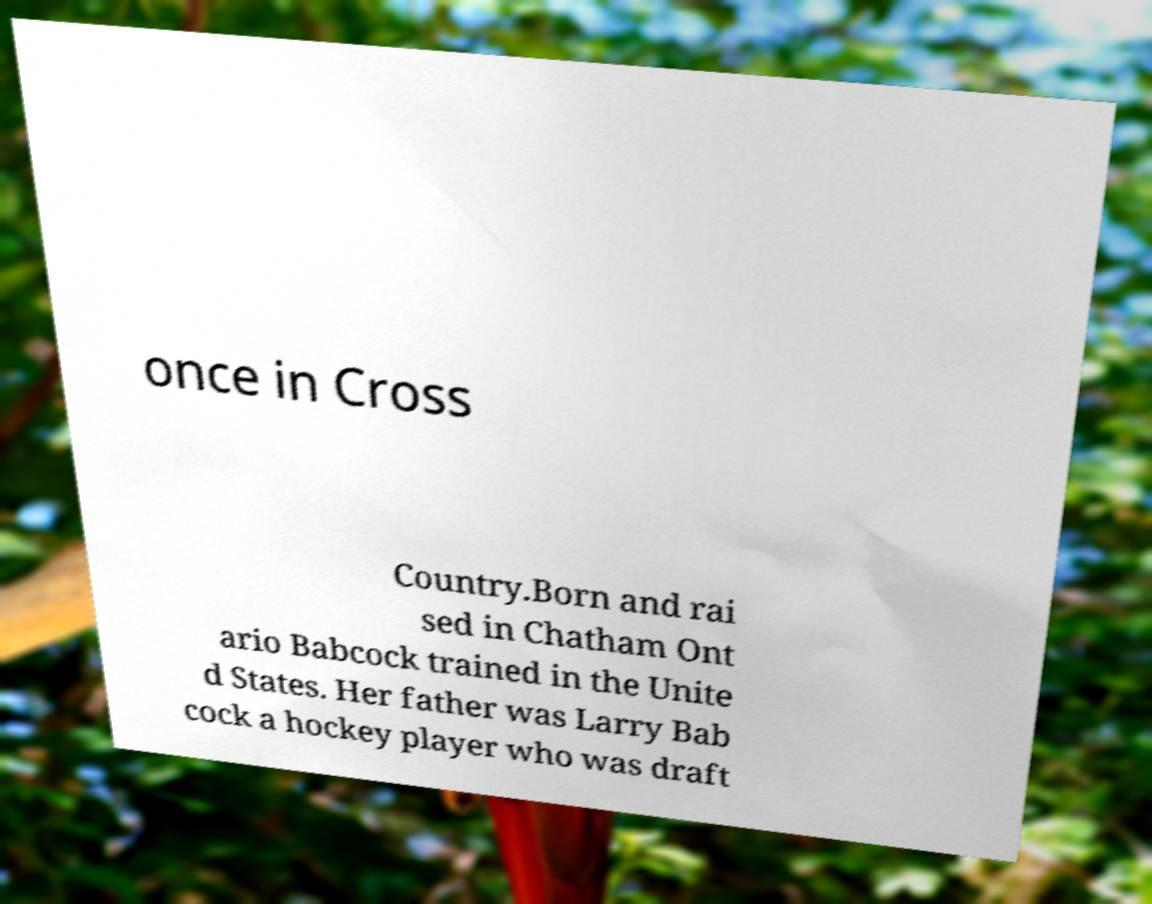Can you accurately transcribe the text from the provided image for me? once in Cross Country.Born and rai sed in Chatham Ont ario Babcock trained in the Unite d States. Her father was Larry Bab cock a hockey player who was draft 